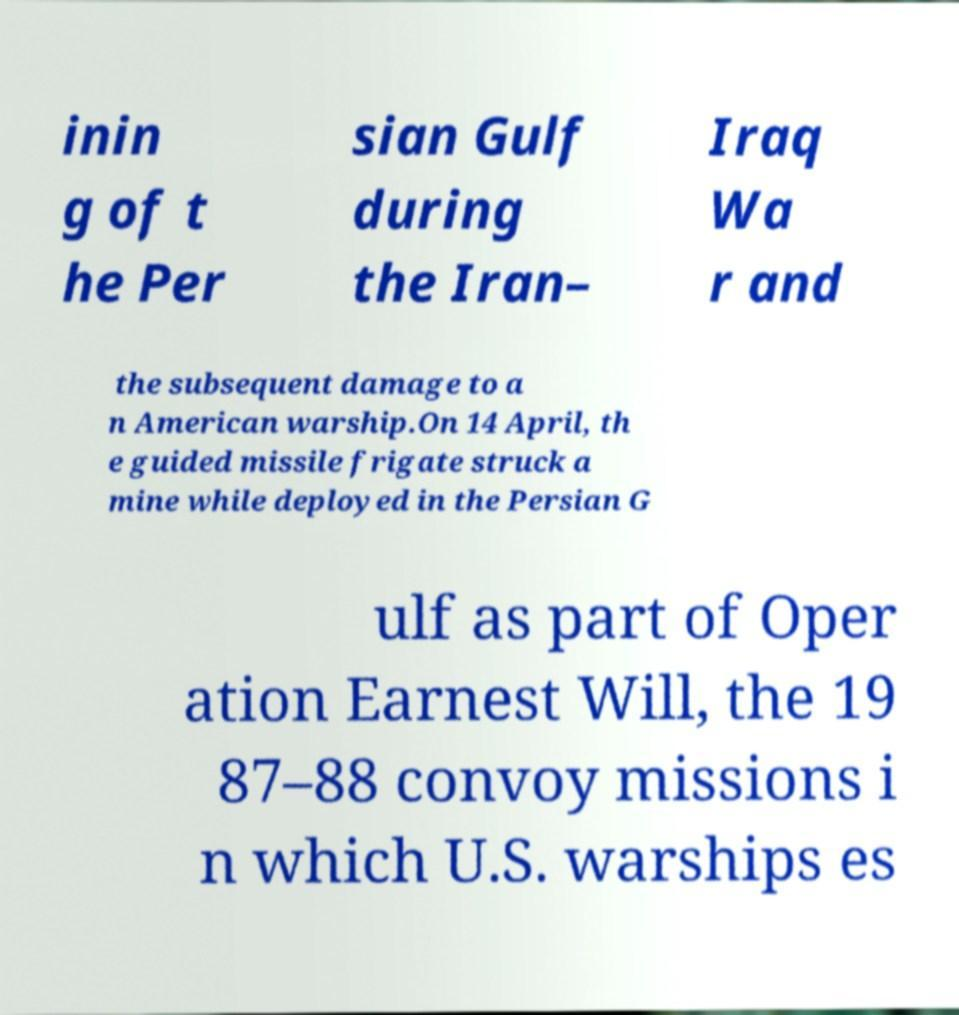Please read and relay the text visible in this image. What does it say? inin g of t he Per sian Gulf during the Iran– Iraq Wa r and the subsequent damage to a n American warship.On 14 April, th e guided missile frigate struck a mine while deployed in the Persian G ulf as part of Oper ation Earnest Will, the 19 87–88 convoy missions i n which U.S. warships es 